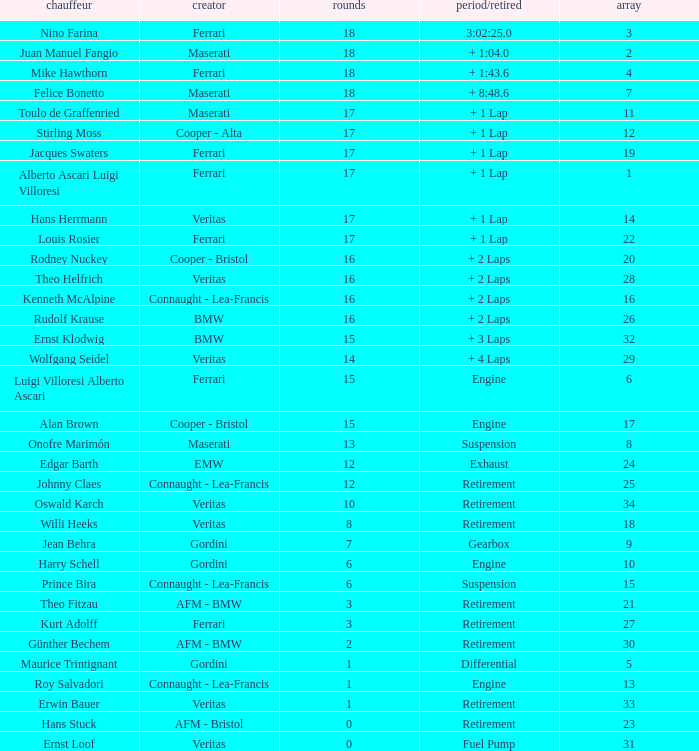Who has the low lap total in a maserati with grid 2? 18.0. 